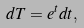Convert formula to latex. <formula><loc_0><loc_0><loc_500><loc_500>d T = e ^ { t } d t ,</formula> 